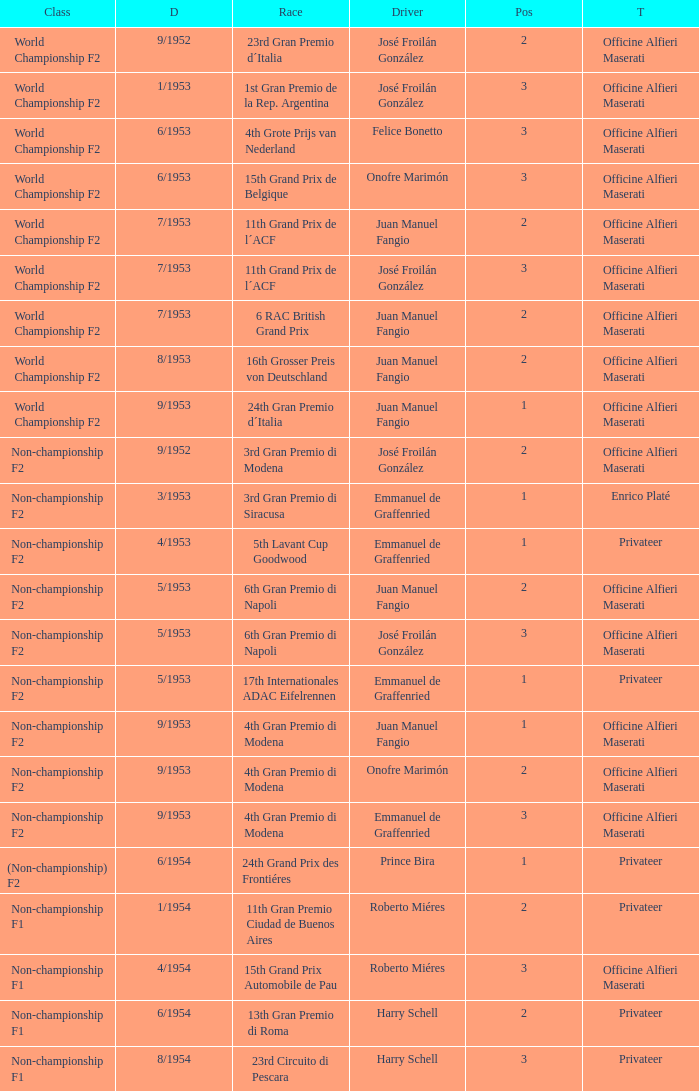What team has a drive name emmanuel de graffenried and a position larger than 1 as well as the date of 9/1953? Officine Alfieri Maserati. 